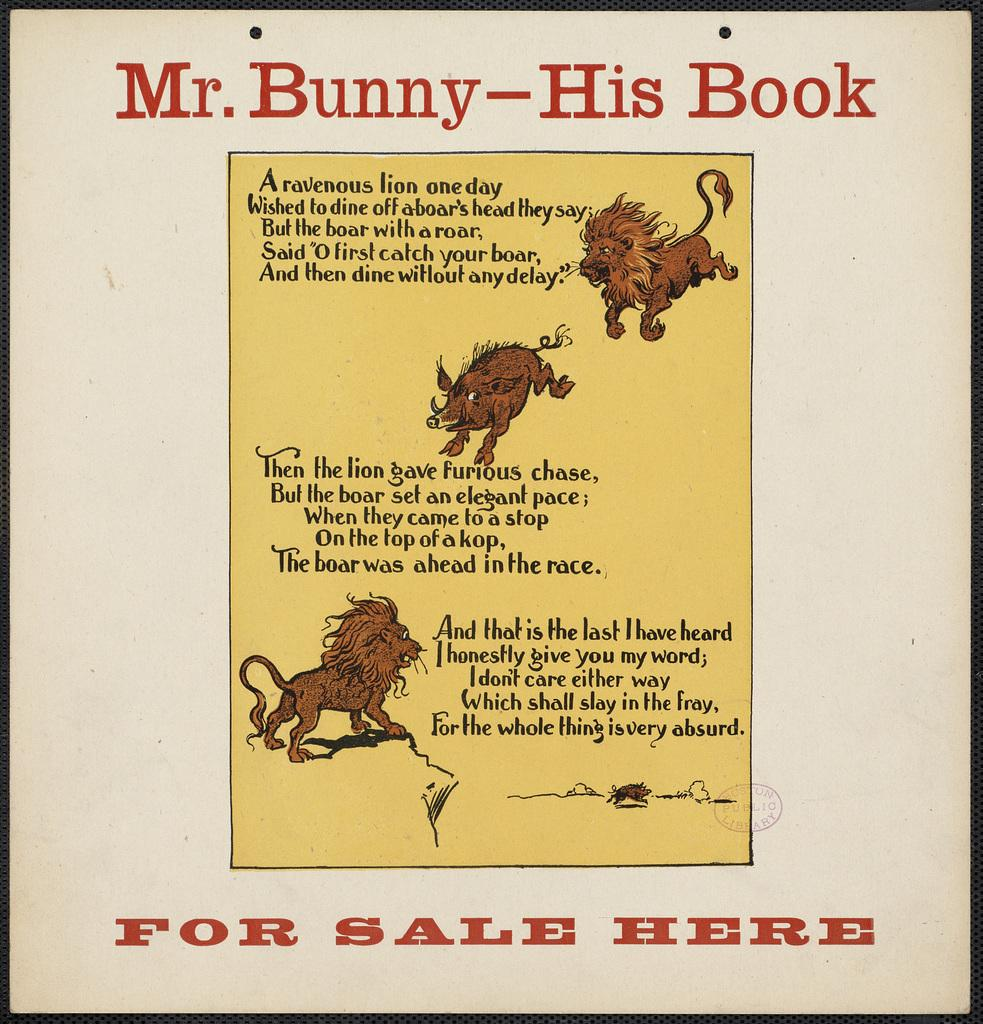What is the main subject of the image? The main subject of the image is a picture of a book cover. What can be seen on the book cover? The book cover has text and pictures on it. What type of bomb is depicted on the book cover? There is no bomb present on the book cover; it features text and pictures related to the book. 